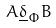<formula> <loc_0><loc_0><loc_500><loc_500>A \underline { \delta } _ { \Phi } B</formula> 